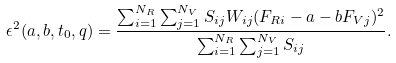Convert formula to latex. <formula><loc_0><loc_0><loc_500><loc_500>\epsilon ^ { 2 } ( a , b , t _ { 0 } , q ) = \frac { \sum _ { i = 1 } ^ { N _ { R } } \sum _ { j = 1 } ^ { N _ { V } } S _ { i j } W _ { i j } ( F _ { R i } - a - b F _ { V j } ) ^ { 2 } } { \sum _ { i = 1 } ^ { N _ { R } } \sum _ { j = 1 } ^ { N _ { V } } S _ { i j } } .</formula> 